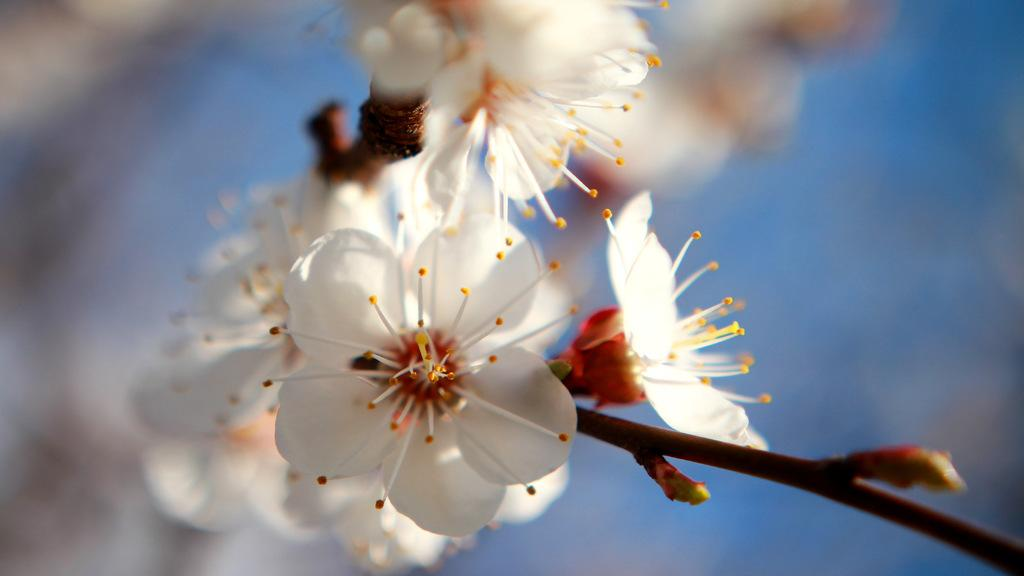What type of flowers can be seen in the image? There are white color flowers in the image. Can you describe the background of the image? The background of the image is blurred. How do the giants interact with the flowers in the image? There are no giants present in the image, so they cannot interact with the flowers. What part of the body is the neck associated with in the image? There is no reference to a neck or any body parts in the image, as it only features white color flowers and a blurred background. 